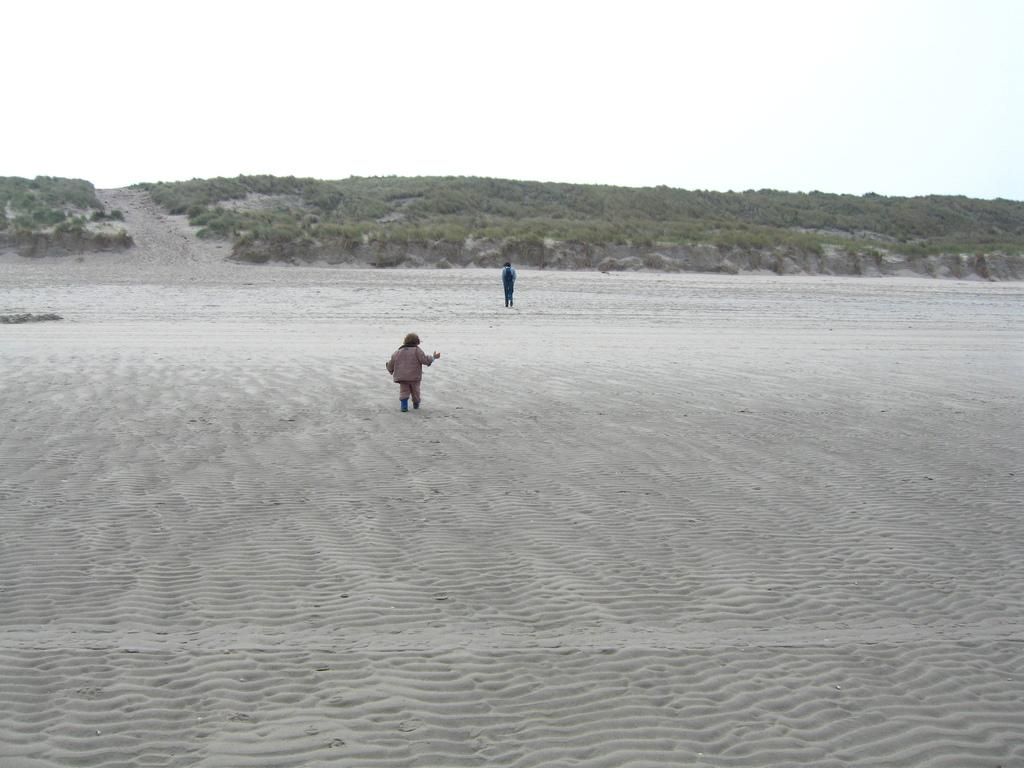How many people are present in the image? There are two people in the image. What is at the bottom of the image? There is sand at the bottom of the image. What can be seen in the background of the image? There are hills and the sky visible in the background of the image. What type of amusement can be seen on the gate in the image? There is no gate present in the image, and therefore no amusement can be seen on it. 